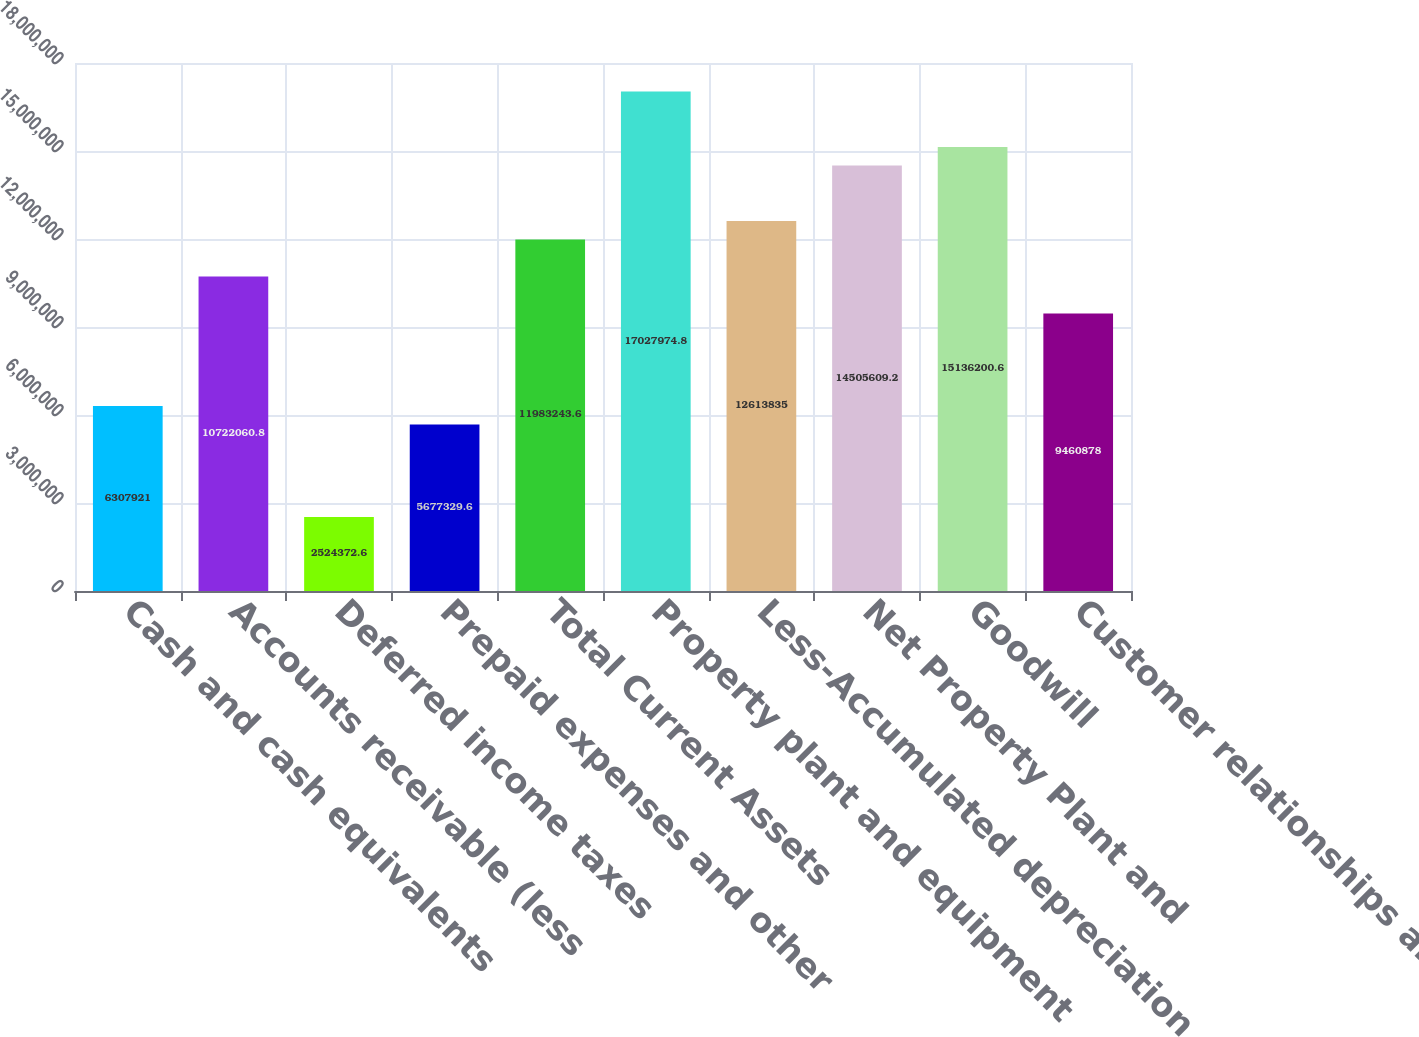Convert chart. <chart><loc_0><loc_0><loc_500><loc_500><bar_chart><fcel>Cash and cash equivalents<fcel>Accounts receivable (less<fcel>Deferred income taxes<fcel>Prepaid expenses and other<fcel>Total Current Assets<fcel>Property plant and equipment<fcel>Less-Accumulated depreciation<fcel>Net Property Plant and<fcel>Goodwill<fcel>Customer relationships and<nl><fcel>6.30792e+06<fcel>1.07221e+07<fcel>2.52437e+06<fcel>5.67733e+06<fcel>1.19832e+07<fcel>1.7028e+07<fcel>1.26138e+07<fcel>1.45056e+07<fcel>1.51362e+07<fcel>9.46088e+06<nl></chart> 